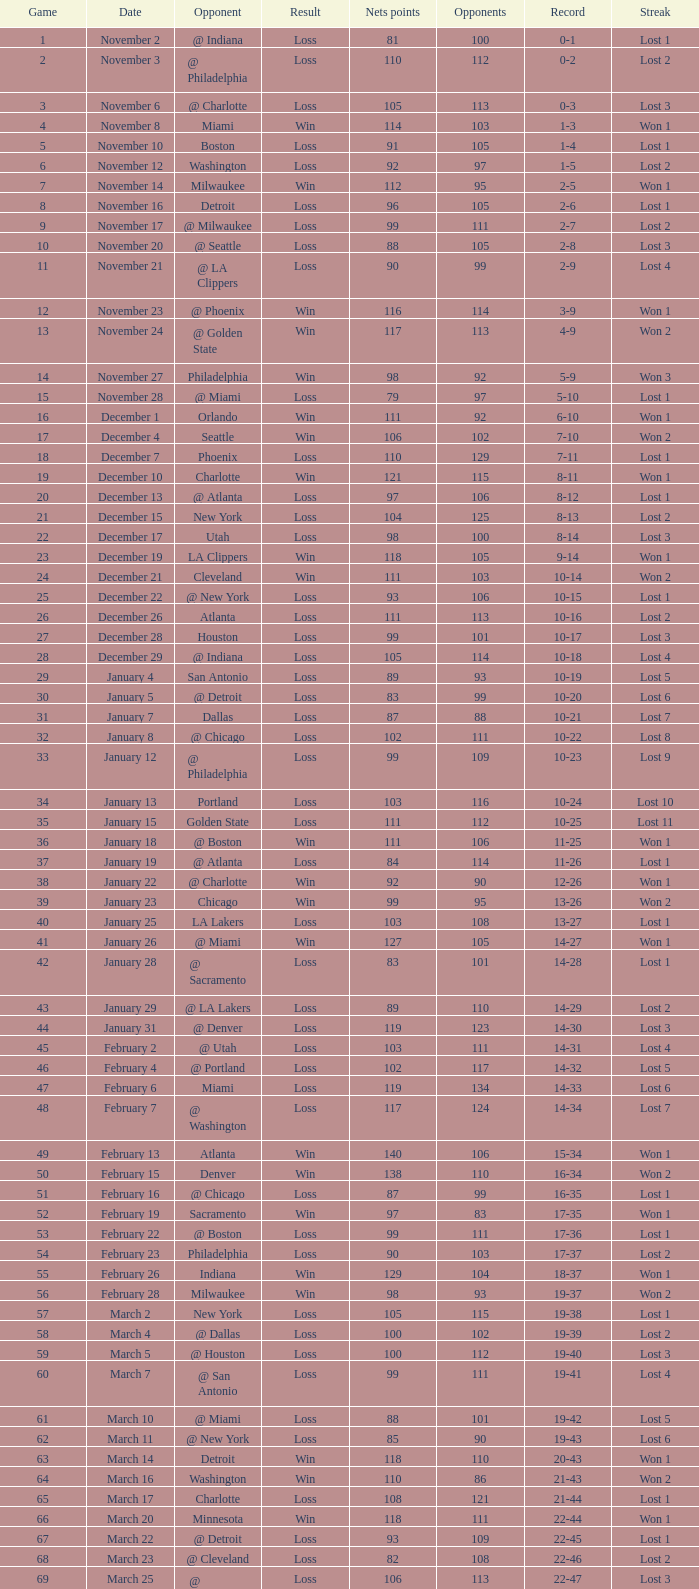What was the typical point sum for the nets in contests preceding contest 9 where the rival teams achieved below 95? None. 